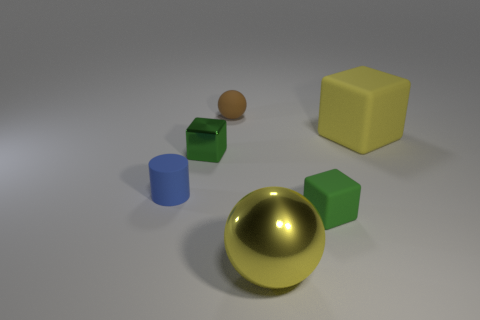There is a matte block on the left side of the yellow cube; does it have the same color as the block left of the large yellow sphere?
Make the answer very short. Yes. Is the number of rubber things in front of the tiny brown matte ball greater than the number of tiny metal things?
Offer a terse response. Yes. What is the material of the cylinder?
Your response must be concise. Rubber. What shape is the tiny brown object that is the same material as the small blue object?
Offer a terse response. Sphere. There is a ball to the right of the rubber sphere behind the blue matte object; what size is it?
Give a very brief answer. Large. What color is the small matte thing that is behind the large yellow matte cube?
Your answer should be compact. Brown. Are there any large yellow things of the same shape as the tiny brown object?
Your answer should be compact. Yes. Are there fewer small brown spheres in front of the tiny green shiny thing than tiny brown rubber objects that are in front of the big yellow shiny ball?
Offer a very short reply. No. What color is the tiny metal cube?
Make the answer very short. Green. Is there a small matte ball behind the green block that is left of the green matte thing?
Your response must be concise. Yes. 